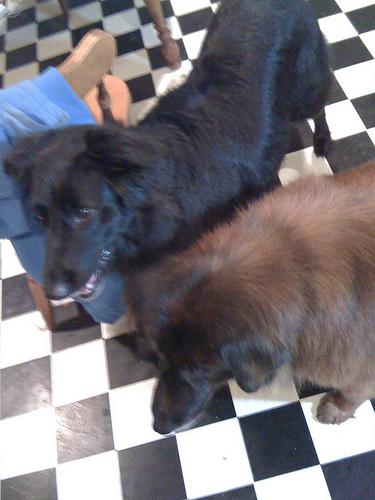Question: what is standing?
Choices:
A. Man.
B. Woman.
C. Dog.
D. Animals.
Answer with the letter. Answer: D Question: what pattern is the floor?
Choices:
A. Planks.
B. Squares.
C. Checkered.
D. Chevrons.
Answer with the letter. Answer: C Question: where are the animals standing on?
Choices:
A. Grass.
B. The floor.
C. Hay.
D. Dirt.
Answer with the letter. Answer: B Question: what color is the animal on the left?
Choices:
A. White.
B. Brown.
C. Black.
D. Gray.
Answer with the letter. Answer: C Question: who is looking down?
Choices:
A. Small girl.
B. Tall man.
C. Grey dog.
D. Animal on right.
Answer with the letter. Answer: D 